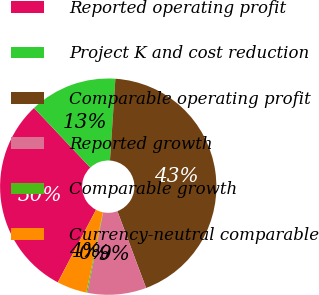Convert chart to OTSL. <chart><loc_0><loc_0><loc_500><loc_500><pie_chart><fcel>Reported operating profit<fcel>Project K and cost reduction<fcel>Comparable operating profit<fcel>Reported growth<fcel>Comparable growth<fcel>Currency-neutral comparable<nl><fcel>30.24%<fcel>13.09%<fcel>43.25%<fcel>8.78%<fcel>0.16%<fcel>4.47%<nl></chart> 